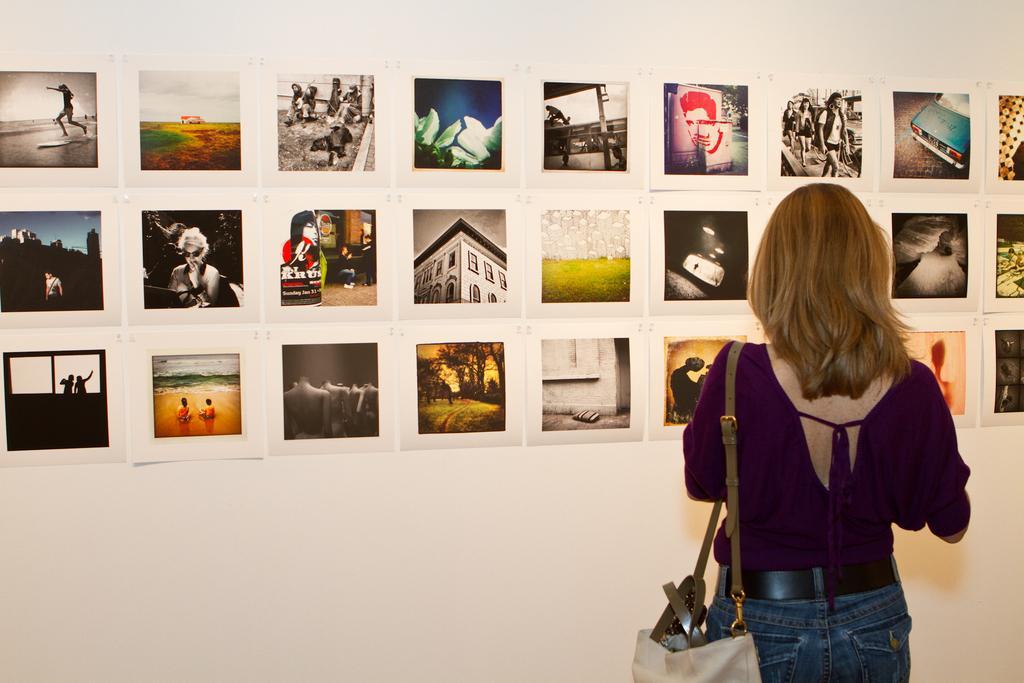Can you describe this image briefly? In this image I can see a woman is standing on the floor and is wearing a bag. In the background I can see wall paintings on a wall. This image is taken, may be in a hall. 